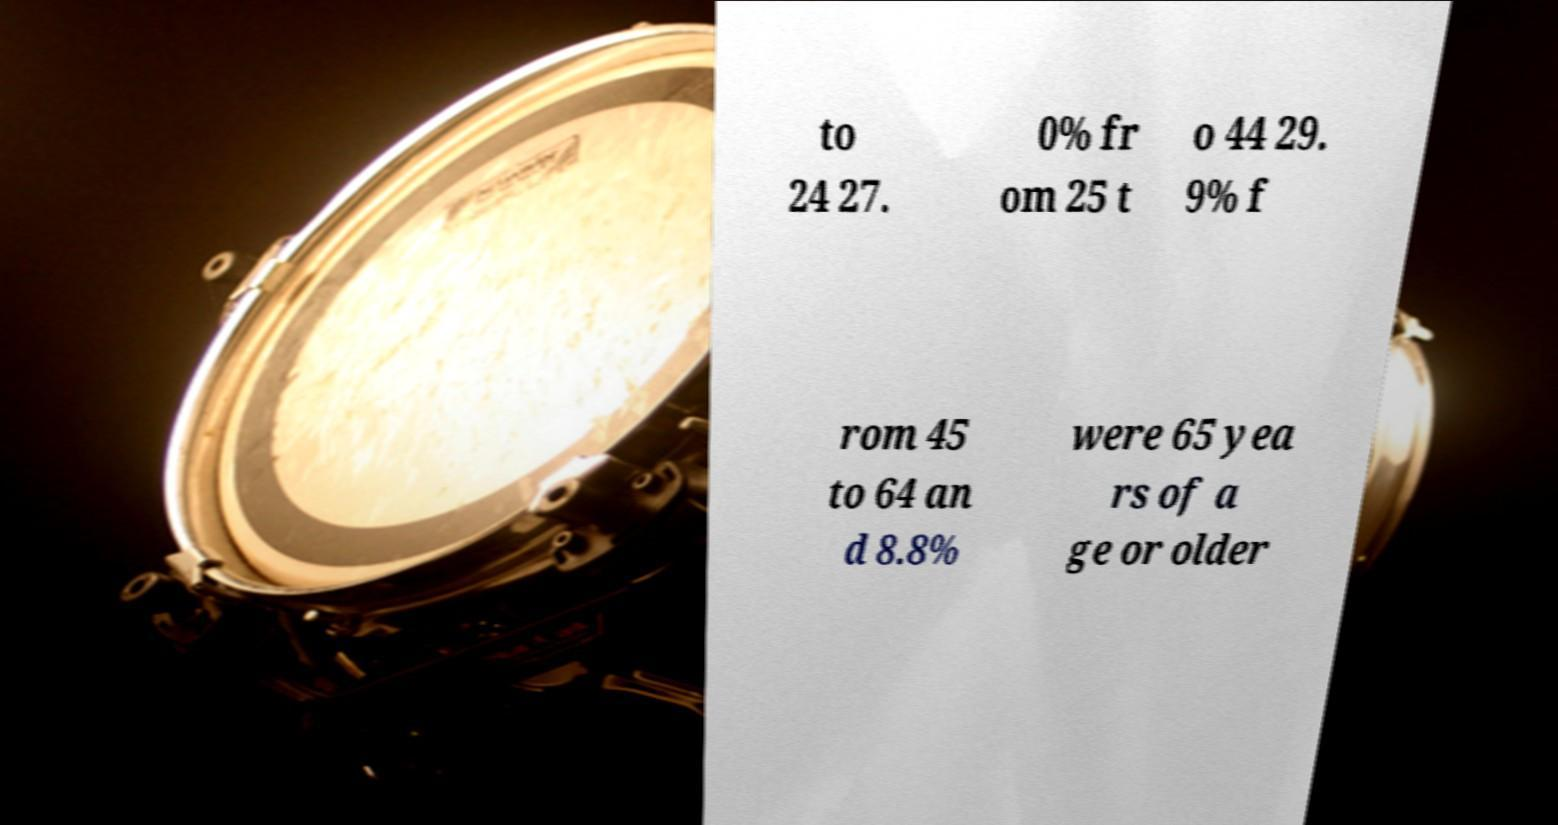Can you read and provide the text displayed in the image?This photo seems to have some interesting text. Can you extract and type it out for me? to 24 27. 0% fr om 25 t o 44 29. 9% f rom 45 to 64 an d 8.8% were 65 yea rs of a ge or older 